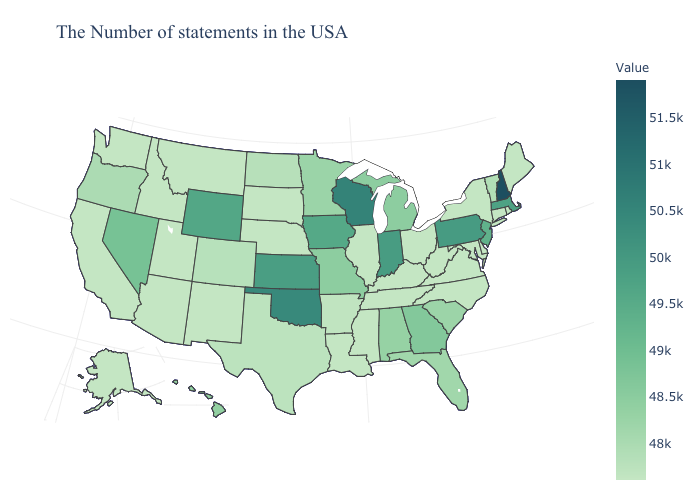Does Vermont have a higher value than New Hampshire?
Answer briefly. No. Does New Hampshire have the highest value in the Northeast?
Keep it brief. Yes. Among the states that border Maryland , does Virginia have the highest value?
Give a very brief answer. No. Which states have the highest value in the USA?
Write a very short answer. New Hampshire. Does Delaware have the lowest value in the USA?
Concise answer only. Yes. Which states have the highest value in the USA?
Keep it brief. New Hampshire. Among the states that border South Carolina , does North Carolina have the highest value?
Keep it brief. No. Among the states that border Minnesota , does South Dakota have the lowest value?
Write a very short answer. Yes. Which states have the lowest value in the MidWest?
Quick response, please. Ohio, Illinois, Nebraska, South Dakota. 